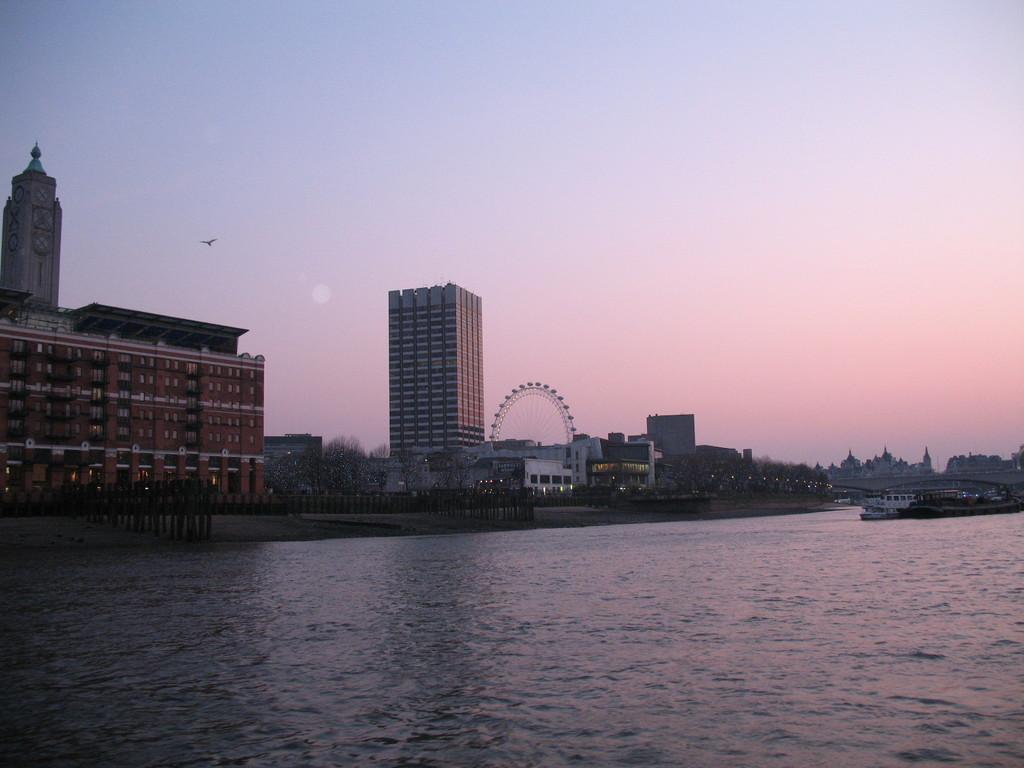What type of structures are present in the image? There are buildings with windows in the image. What is the large, circular object in the image? There is a giant wheel in the image. What type of vegetation can be seen in the image? There are trees in the image. What body of water is visible in the image? There is water visible in the image. What type of vehicle is present in the image? There is a boat in the image. What part of the natural environment is visible in the image? The sky is visible in the image. How many apples are hanging from the trees in the image? There are no apples visible in the image; only trees are present. What color is the scarf worn by the giant wheel in the image? There is no scarf present in the image, as the giant wheel is an inanimate object. 